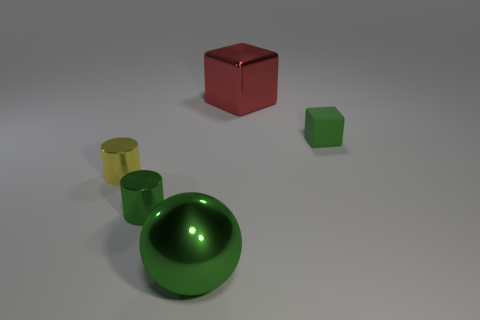Are there any other things that have the same material as the small cube?
Your answer should be compact. No. There is a tiny green thing on the left side of the large green metal object; what is its shape?
Provide a short and direct response. Cylinder. Is the number of yellow objects greater than the number of small metal objects?
Your response must be concise. No. Is the color of the small object that is to the right of the large green thing the same as the large sphere?
Make the answer very short. Yes. What number of objects are objects left of the matte block or small cylinders in front of the small yellow cylinder?
Make the answer very short. 4. What number of objects are in front of the large red thing and right of the green sphere?
Your response must be concise. 1. Are the green block and the ball made of the same material?
Your answer should be compact. No. What shape is the big metal object behind the big object in front of the small green thing that is behind the small yellow object?
Make the answer very short. Cube. What material is the object that is both right of the big green metal thing and in front of the large red cube?
Your answer should be very brief. Rubber. There is a tiny thing that is in front of the cylinder that is behind the tiny cylinder right of the yellow cylinder; what color is it?
Your answer should be compact. Green. 